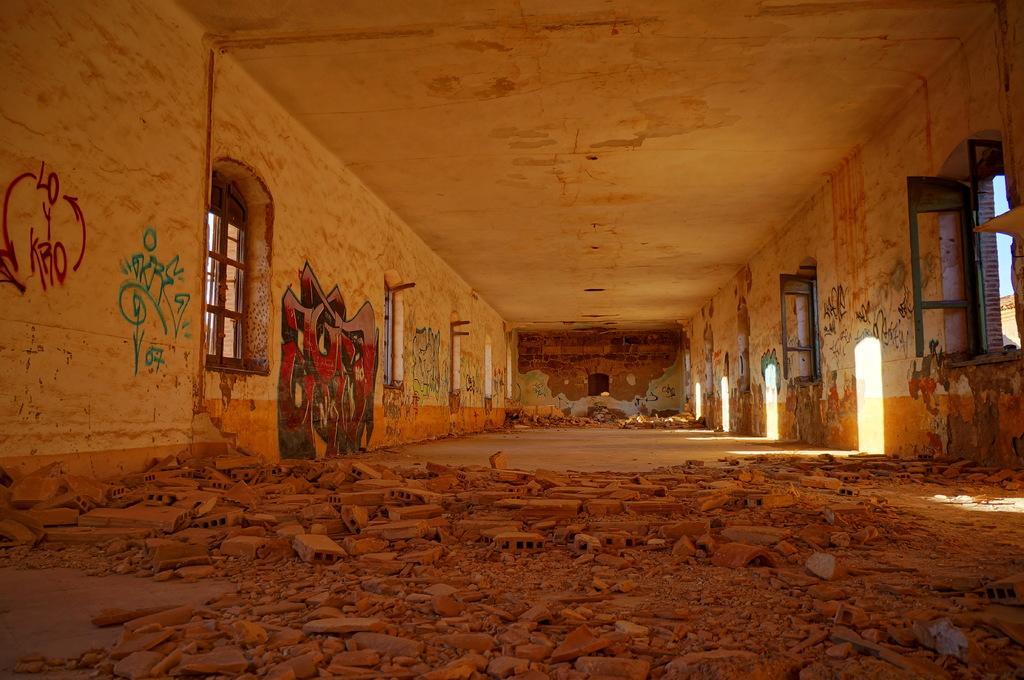Describe this image in one or two sentences. In this image on the right side and left side there are some windows and wall, at the bottom there are some bricks and sand. On the top there is ceiling and in the center there is a wall, and on the wall there is some text. 